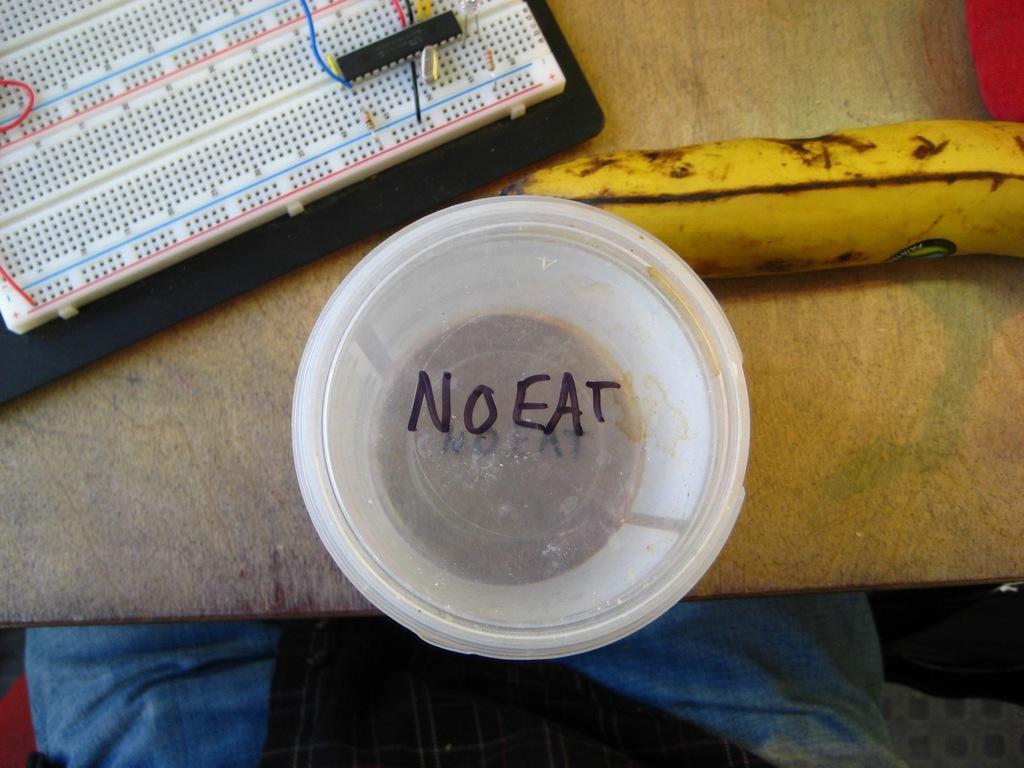Please provide a concise description of this image. In this image there is a plastic container, there is text on the plastic container, there is a banana, there is a board towards the top of the image, there are objects on the wooden surface, there are person's legs towards the bottom of the image. 